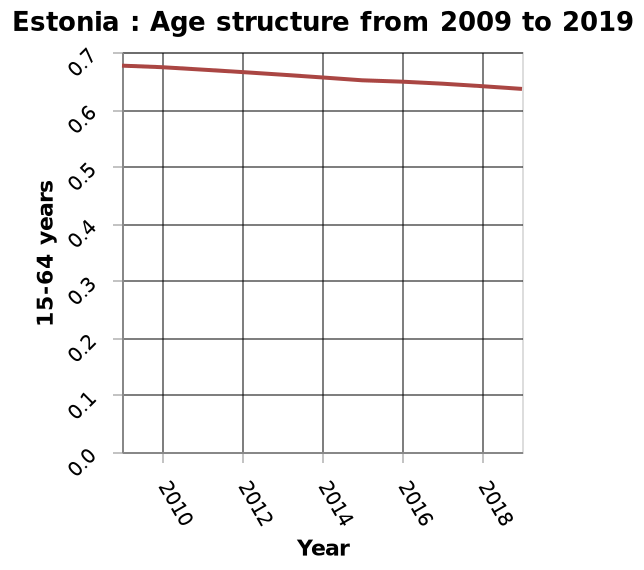<image>
please describe the details of the chart Estonia : Age structure from 2009 to 2019 is a line plot. The y-axis plots 15-64 years. There is a linear scale of range 2010 to 2018 along the x-axis, marked Year. What is the age group plotted on the y-axis of the line plot?  The age group plotted on the y-axis is 15-64 years. What is the range of the x-axis in the line plot? The range of the x-axis in the line plot is from 2010 to 2018. Is Estonia: Age structure from 2009 to 2019 a bar plot? No.Estonia : Age structure from 2009 to 2019 is a line plot. The y-axis plots 15-64 years. There is a linear scale of range 2010 to 2018 along the x-axis, marked Year. 